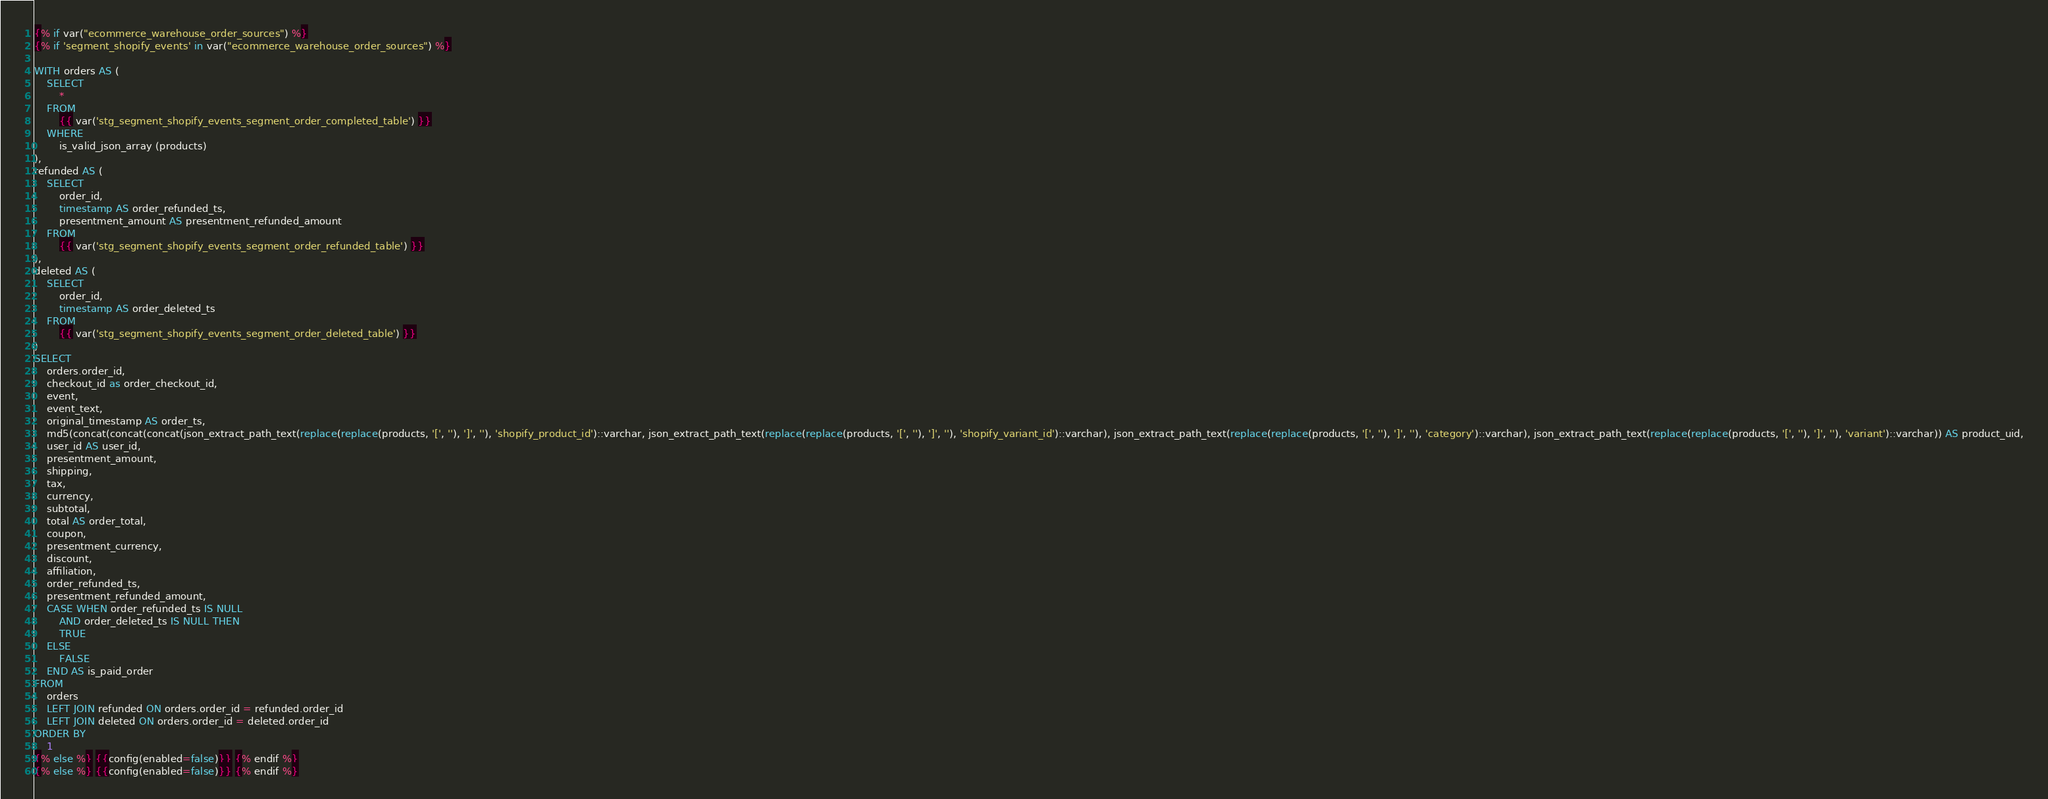<code> <loc_0><loc_0><loc_500><loc_500><_SQL_>{% if var("ecommerce_warehouse_order_sources") %}
{% if 'segment_shopify_events' in var("ecommerce_warehouse_order_sources") %}

WITH orders AS (
	SELECT
		*
	FROM
		{{ var('stg_segment_shopify_events_segment_order_completed_table') }}
	WHERE
		is_valid_json_array (products)
),
refunded AS (
	SELECT
		order_id,
		timestamp AS order_refunded_ts,
		presentment_amount AS presentment_refunded_amount
	FROM
		{{ var('stg_segment_shopify_events_segment_order_refunded_table') }}
),
deleted AS (
	SELECT
		order_id,
		timestamp AS order_deleted_ts
	FROM
		{{ var('stg_segment_shopify_events_segment_order_deleted_table') }}
)
SELECT
	orders.order_id,
	checkout_id as order_checkout_id,
	event,
	event_text,
	original_timestamp AS order_ts,
	md5(concat(concat(concat(json_extract_path_text(replace(replace(products, '[', ''), ']', ''), 'shopify_product_id')::varchar, json_extract_path_text(replace(replace(products, '[', ''), ']', ''), 'shopify_variant_id')::varchar), json_extract_path_text(replace(replace(products, '[', ''), ']', ''), 'category')::varchar), json_extract_path_text(replace(replace(products, '[', ''), ']', ''), 'variant')::varchar)) AS product_uid,
	user_id AS user_id,
	presentment_amount,
	shipping,
	tax,
	currency,
	subtotal,
	total AS order_total,
	coupon,
	presentment_currency,
	discount,
	affiliation,
	order_refunded_ts,
	presentment_refunded_amount,
	CASE WHEN order_refunded_ts IS NULL
		AND order_deleted_ts IS NULL THEN
		TRUE
	ELSE
		FALSE
	END AS is_paid_order
FROM
	orders
	LEFT JOIN refunded ON orders.order_id = refunded.order_id
	LEFT JOIN deleted ON orders.order_id = deleted.order_id
ORDER BY
	1
{% else %} {{config(enabled=false)}} {% endif %}
{% else %} {{config(enabled=false)}} {% endif %}
</code> 